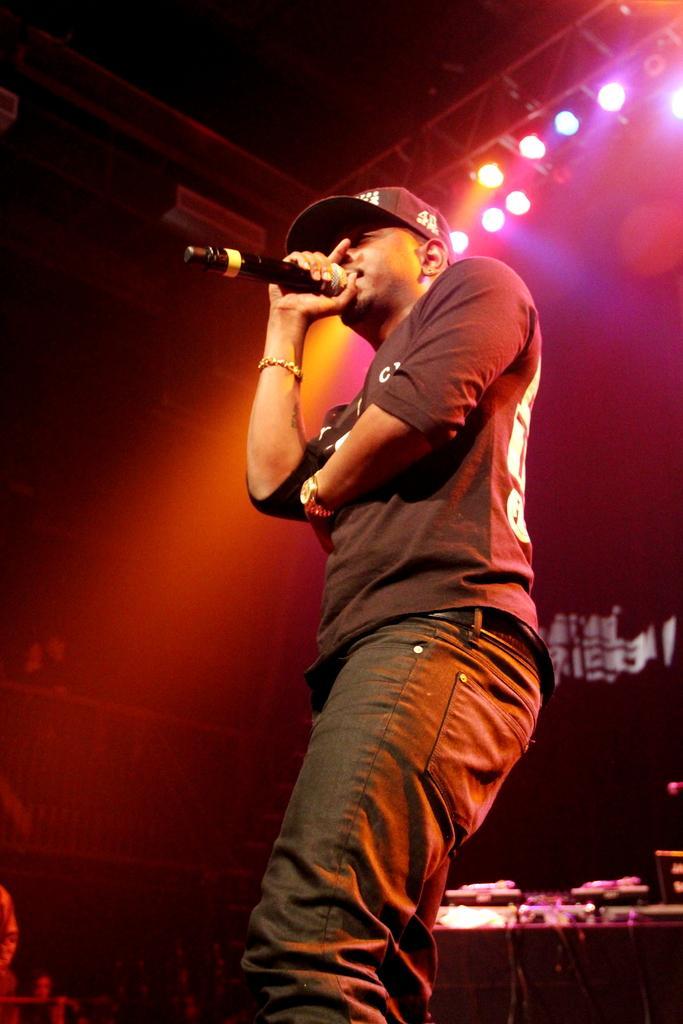Can you describe this image briefly? This picture shows a person standing, singing and his holding a microphone in his right hand, he wore a cap and a watch to his left and in the background there is a table with some equipment and on the ceiling they are disco lights attached. 